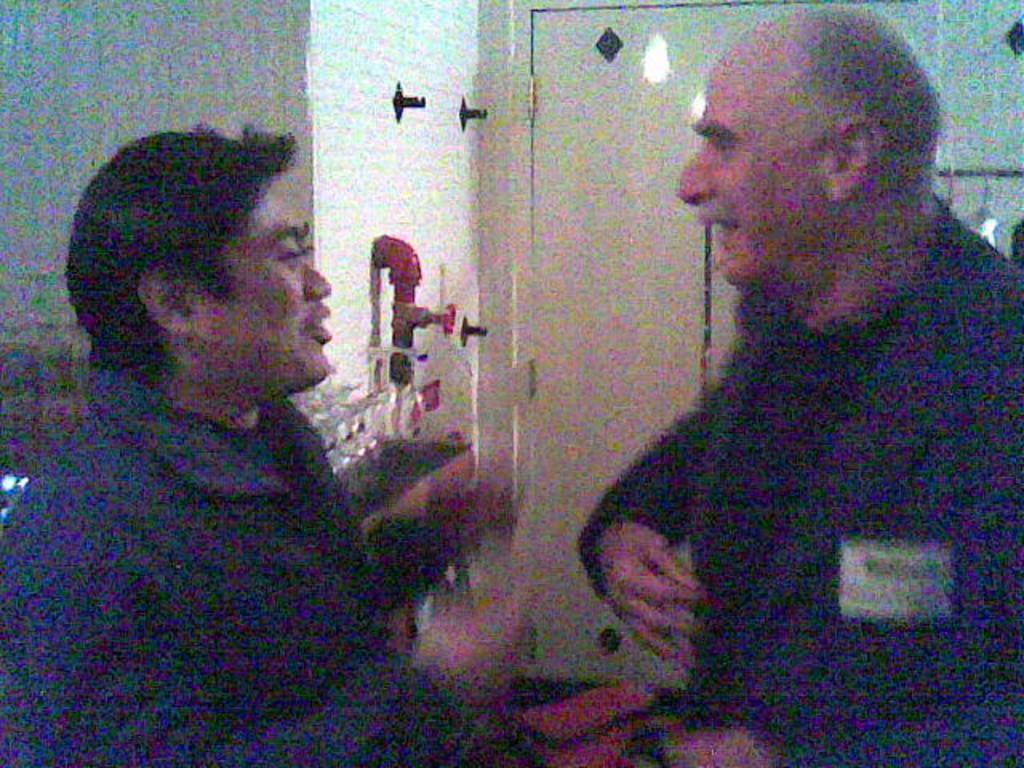Describe this image in one or two sentences. This image consists of two persons. They are talking. There is a door in the middle. 